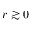<formula> <loc_0><loc_0><loc_500><loc_500>r \gtrsim 0</formula> 